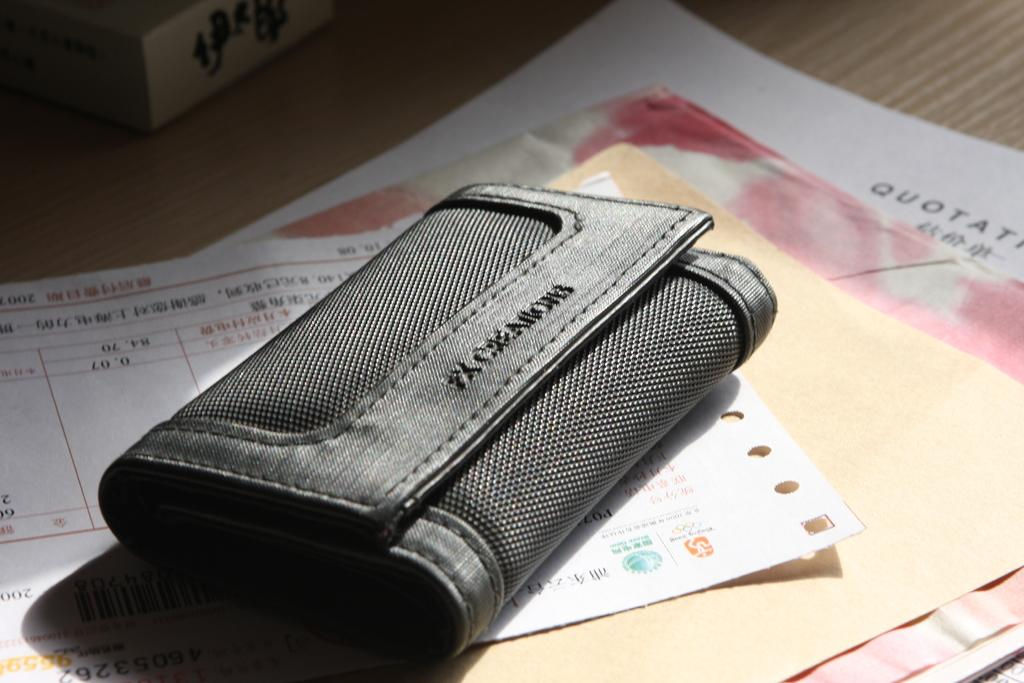What is the main object in the center of the image? There is a wallet in the center of the image. What is located at the bottom of the image? There are papers at the bottom of the image. What is situated at the top of the image? There is a box at the top of the image. Are there any other boxes in the image? Yes, there is another box in the center of the image. What type of brass instrument is being played in the image? There is no brass instrument or any musical instrument present in the image. What role does the father play in the image? There is no reference to a father or any person in the image. 